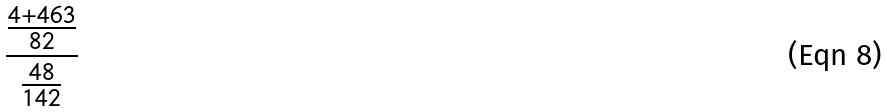Convert formula to latex. <formula><loc_0><loc_0><loc_500><loc_500>\frac { \frac { 4 + 4 6 3 } { 8 2 } } { \frac { 4 8 } { 1 4 2 } }</formula> 